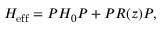<formula> <loc_0><loc_0><loc_500><loc_500>H _ { e f f } = P H _ { 0 } P + P R ( z ) P ,</formula> 